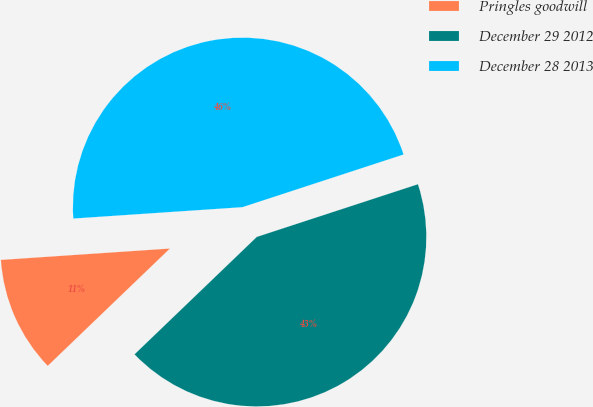Convert chart. <chart><loc_0><loc_0><loc_500><loc_500><pie_chart><fcel>Pringles goodwill<fcel>December 29 2012<fcel>December 28 2013<nl><fcel>11.11%<fcel>42.85%<fcel>46.04%<nl></chart> 